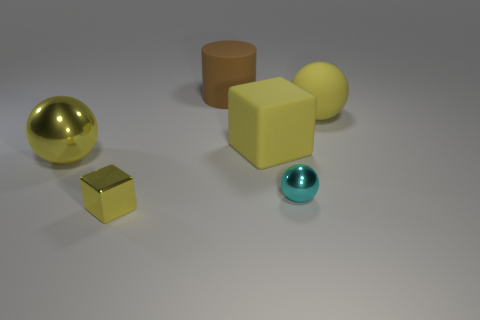How many yellow balls must be subtracted to get 1 yellow balls? 1 Subtract all large balls. How many balls are left? 1 Add 1 yellow shiny balls. How many objects exist? 7 Subtract all cylinders. How many objects are left? 5 Add 2 yellow blocks. How many yellow blocks exist? 4 Subtract 0 blue balls. How many objects are left? 6 Subtract all cyan metal spheres. Subtract all matte cylinders. How many objects are left? 4 Add 4 big yellow balls. How many big yellow balls are left? 6 